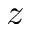Convert formula to latex. <formula><loc_0><loc_0><loc_500><loc_500>z</formula> 